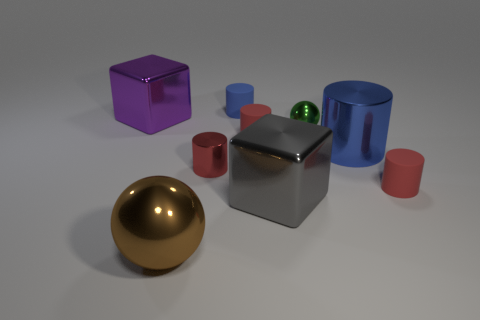What is the color of the small metallic ball?
Offer a terse response. Green. What number of other things are there of the same size as the red metallic thing?
Your answer should be very brief. 4. There is a small blue object that is the same shape as the big blue metallic object; what is it made of?
Your answer should be very brief. Rubber. There is a blue thing behind the tiny red rubber cylinder behind the small red cylinder in front of the red shiny cylinder; what is its material?
Keep it short and to the point. Rubber. What is the size of the sphere that is made of the same material as the brown thing?
Your answer should be compact. Small. Are there any other things that are the same color as the big ball?
Your response must be concise. No. Do the tiny rubber cylinder behind the purple block and the metal cylinder that is on the right side of the big gray thing have the same color?
Ensure brevity in your answer.  Yes. The shiny ball that is behind the large cylinder is what color?
Give a very brief answer. Green. There is a metallic cube that is right of the purple metallic block; does it have the same size as the blue metal cylinder?
Your response must be concise. Yes. Is the number of metallic cylinders less than the number of big objects?
Your answer should be compact. Yes. 